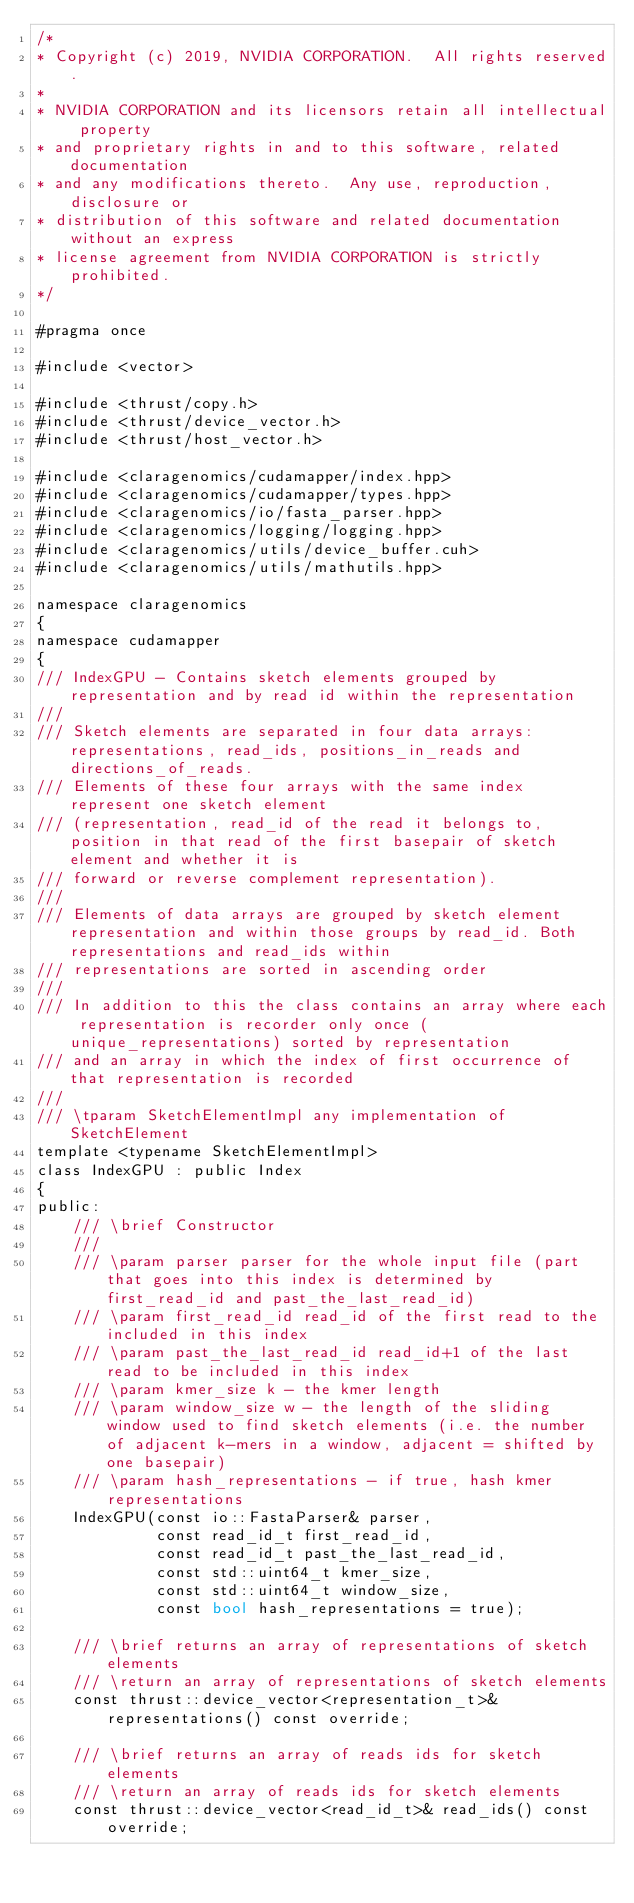<code> <loc_0><loc_0><loc_500><loc_500><_Cuda_>/*
* Copyright (c) 2019, NVIDIA CORPORATION.  All rights reserved.
*
* NVIDIA CORPORATION and its licensors retain all intellectual property
* and proprietary rights in and to this software, related documentation
* and any modifications thereto.  Any use, reproduction, disclosure or
* distribution of this software and related documentation without an express
* license agreement from NVIDIA CORPORATION is strictly prohibited.
*/

#pragma once

#include <vector>

#include <thrust/copy.h>
#include <thrust/device_vector.h>
#include <thrust/host_vector.h>

#include <claragenomics/cudamapper/index.hpp>
#include <claragenomics/cudamapper/types.hpp>
#include <claragenomics/io/fasta_parser.hpp>
#include <claragenomics/logging/logging.hpp>
#include <claragenomics/utils/device_buffer.cuh>
#include <claragenomics/utils/mathutils.hpp>

namespace claragenomics
{
namespace cudamapper
{
/// IndexGPU - Contains sketch elements grouped by representation and by read id within the representation
///
/// Sketch elements are separated in four data arrays: representations, read_ids, positions_in_reads and directions_of_reads.
/// Elements of these four arrays with the same index represent one sketch element
/// (representation, read_id of the read it belongs to, position in that read of the first basepair of sketch element and whether it is
/// forward or reverse complement representation).
///
/// Elements of data arrays are grouped by sketch element representation and within those groups by read_id. Both representations and read_ids within
/// representations are sorted in ascending order
///
/// In addition to this the class contains an array where each representation is recorder only once (unique_representations) sorted by representation
/// and an array in which the index of first occurrence of that representation is recorded
///
/// \tparam SketchElementImpl any implementation of SketchElement
template <typename SketchElementImpl>
class IndexGPU : public Index
{
public:
    /// \brief Constructor
    ///
    /// \param parser parser for the whole input file (part that goes into this index is determined by first_read_id and past_the_last_read_id)
    /// \param first_read_id read_id of the first read to the included in this index
    /// \param past_the_last_read_id read_id+1 of the last read to be included in this index
    /// \param kmer_size k - the kmer length
    /// \param window_size w - the length of the sliding window used to find sketch elements (i.e. the number of adjacent k-mers in a window, adjacent = shifted by one basepair)
    /// \param hash_representations - if true, hash kmer representations
    IndexGPU(const io::FastaParser& parser,
             const read_id_t first_read_id,
             const read_id_t past_the_last_read_id,
             const std::uint64_t kmer_size,
             const std::uint64_t window_size,
             const bool hash_representations = true);

    /// \brief returns an array of representations of sketch elements
    /// \return an array of representations of sketch elements
    const thrust::device_vector<representation_t>& representations() const override;

    /// \brief returns an array of reads ids for sketch elements
    /// \return an array of reads ids for sketch elements
    const thrust::device_vector<read_id_t>& read_ids() const override;
</code> 